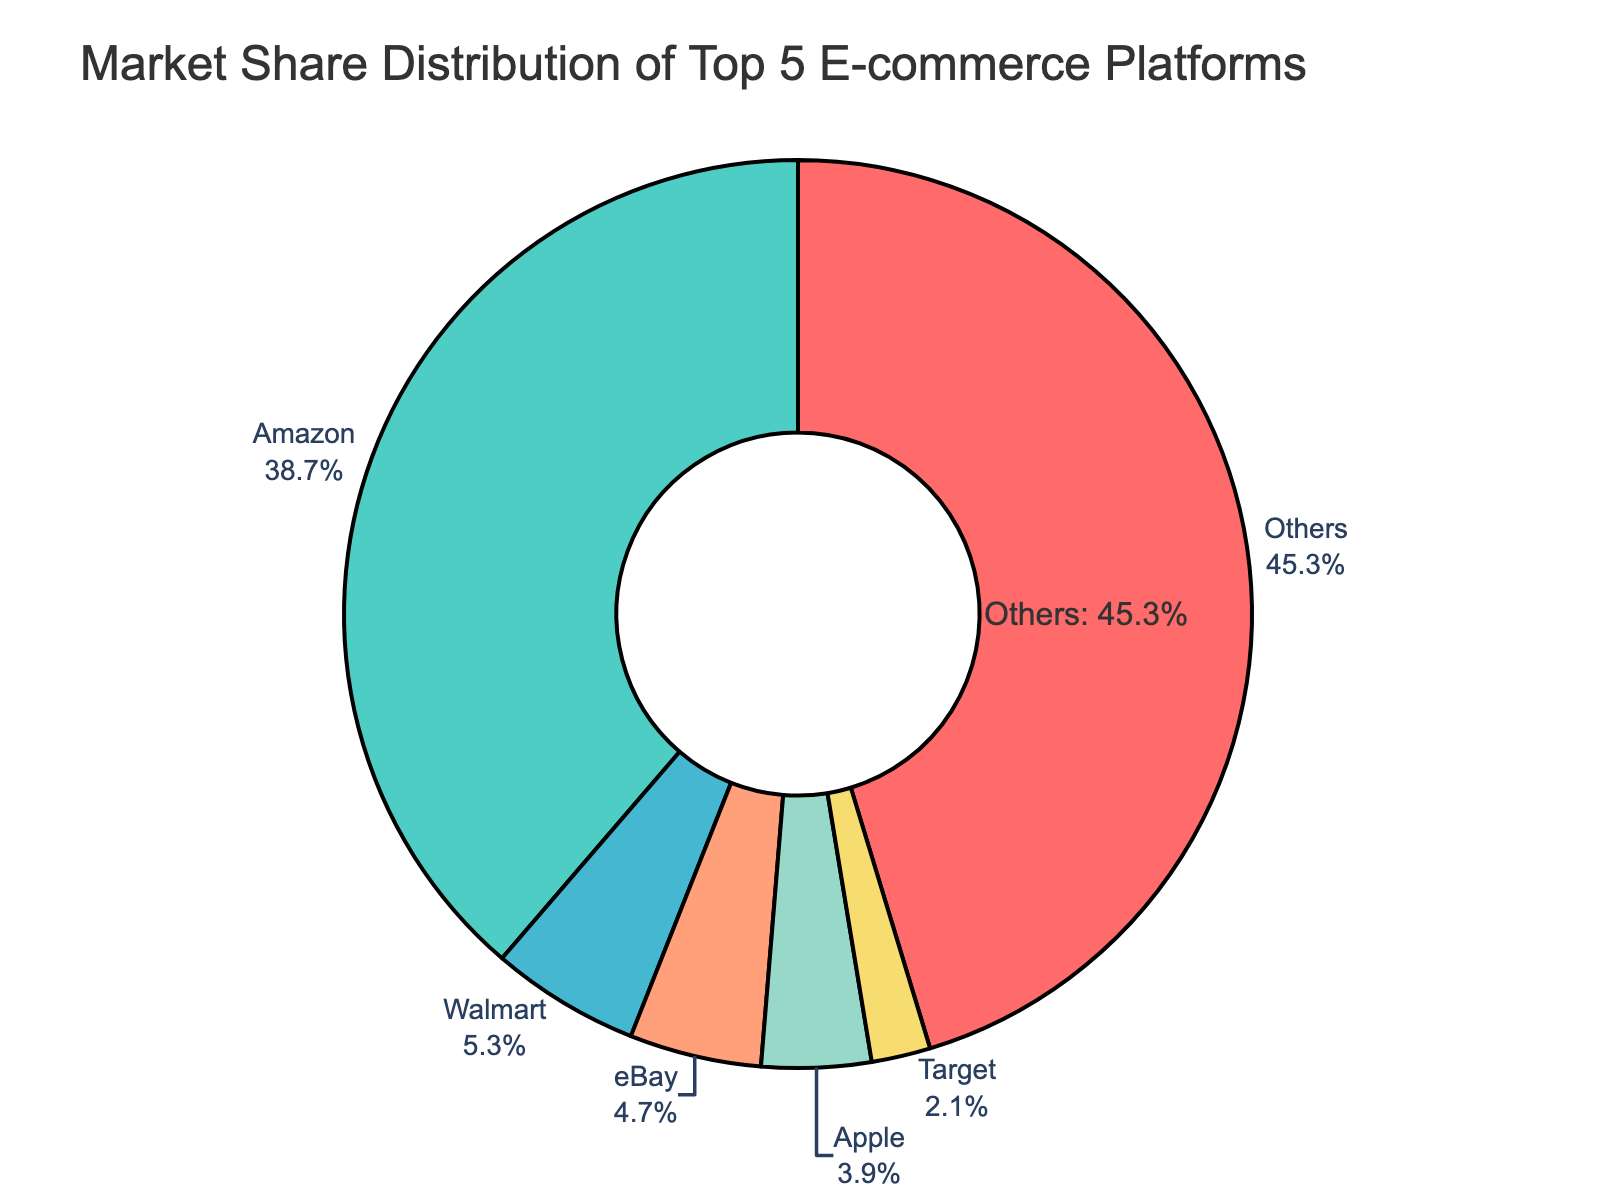Which e-commerce platform has the highest market share? By looking at the sector with the largest area in the pie chart, it is clear that Amazon holds the largest market share.
Answer: Amazon What is the combined market share of Walmart and eBay? To find the combined market share, add the market shares of Walmart (5.3%) and eBay (4.7%). 5.3 + 4.7 = 10
Answer: 10% How much smaller is Apple's market share compared to Amazon's? Subtract Apple's market share (3.9%) from Amazon's market share (38.7%). 38.7 - 3.9 = 34.8
Answer: 34.8% Which platforms have a market share less than 5%? Identify the platforms with market shares smaller than 5%: eBay (4.7%), Apple (3.9%), Target (2.1%).
Answer: eBay, Apple, Target What is the average market share of the top 5 e-commerce platforms? Calculate the sum of the market shares of the top 5 platforms (Amazon, Walmart, eBay, Apple, Target) and divide by 5: (38.7 + 5.3 + 4.7 + 3.9 + 2.1) / 5 = 10.94
Answer: 10.94% What percentage of the market share is not controlled by the named top 5 platforms? The chart indicates a 45.3% market share for "Others". This represents the percentage of the market share not controlled by the top 5 platforms.
Answer: 45.3% Is Walmart's market share more than double that of Target's? Double Target's market share is 2.1 × 2 = 4.2. Since Walmart's market share is 5.3, which is more than 4.2, Walmart's market share is indeed more than double that of Target's.
Answer: Yes What color is used to represent Apple's market share? By examining the pie chart, we can see that the section corresponding to Apple is shaded in a specific color.
Answer: Salmon (light orange) If Amazon's market share increased by 5%, what would be its new market share? To calculate the new market share, add 5% to Amazon's current market share (38.7). 38.7 + 5 = 43.7
Answer: 43.7% Which platform has the smallest market share among the top 5? By comparing the market shares of the top 5 platforms, it is clear that Target has the smallest market share (2.1%).
Answer: Target 